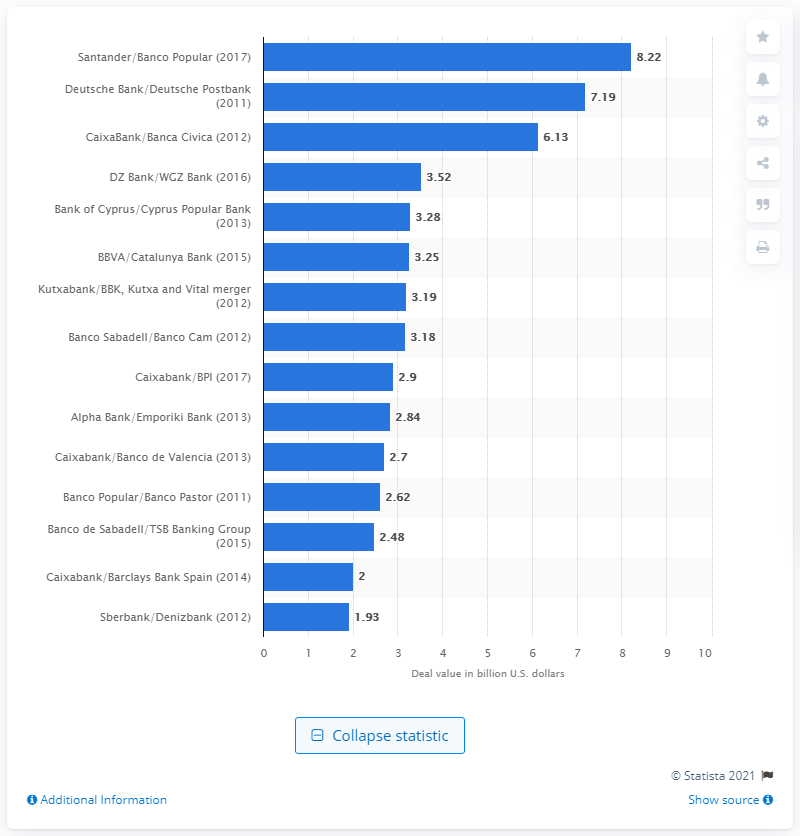List a handful of essential elements in this visual. Santander paid 8.22 billion for the acquisition of Banco Popular. 